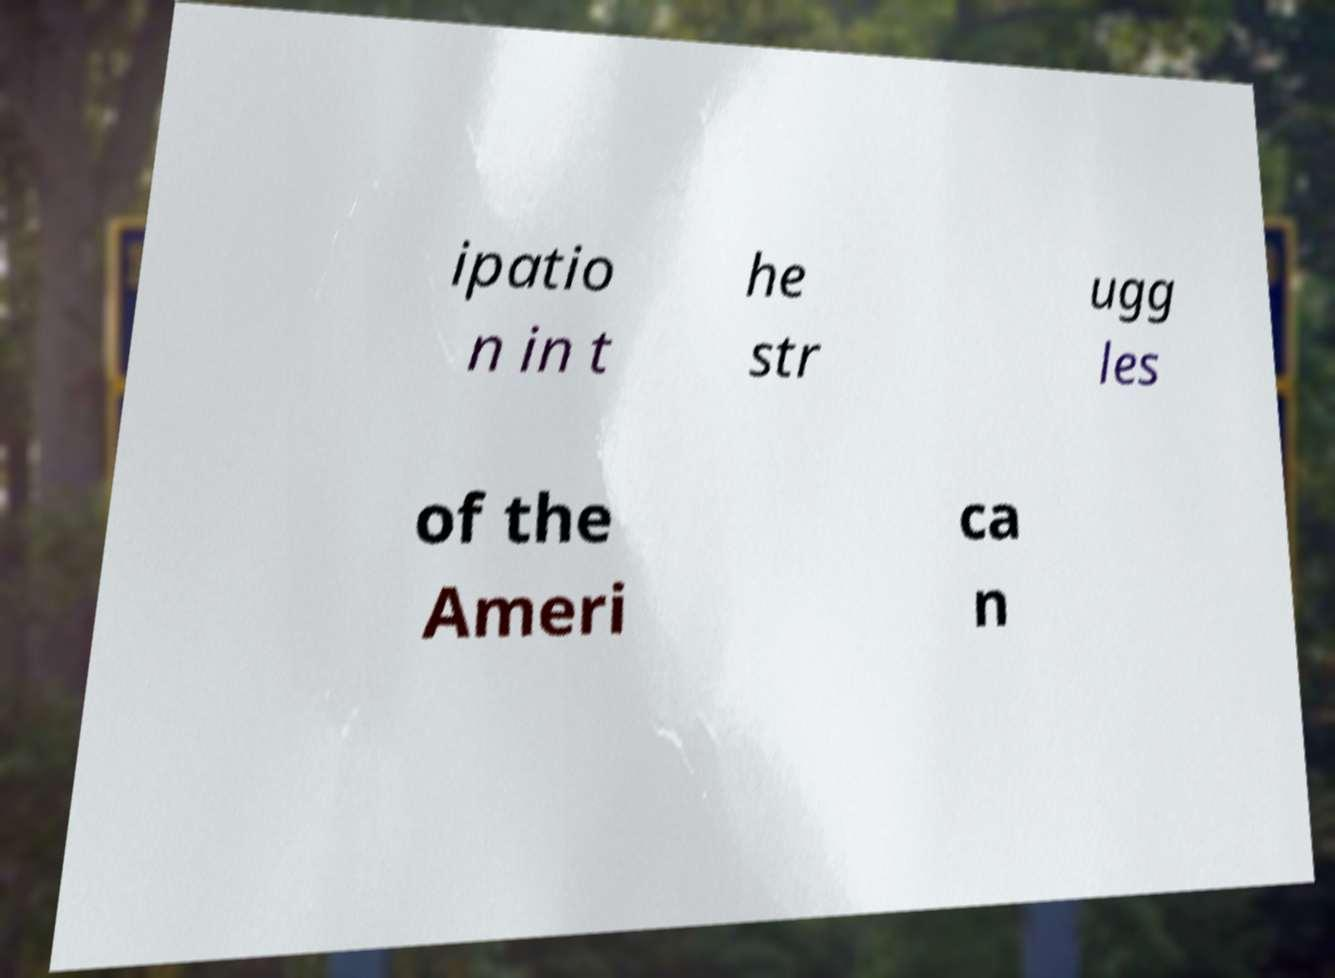What messages or text are displayed in this image? I need them in a readable, typed format. ipatio n in t he str ugg les of the Ameri ca n 